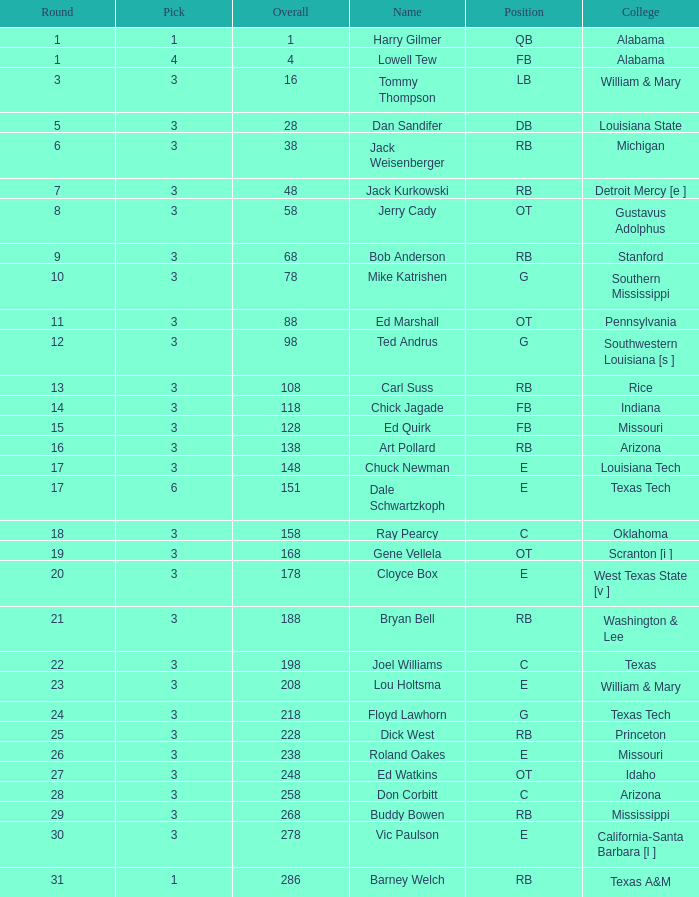Which selection has a round less than 8, and an overall less than 16, and a name of harry gilmer? 1.0. I'm looking to parse the entire table for insights. Could you assist me with that? {'header': ['Round', 'Pick', 'Overall', 'Name', 'Position', 'College'], 'rows': [['1', '1', '1', 'Harry Gilmer', 'QB', 'Alabama'], ['1', '4', '4', 'Lowell Tew', 'FB', 'Alabama'], ['3', '3', '16', 'Tommy Thompson', 'LB', 'William & Mary'], ['5', '3', '28', 'Dan Sandifer', 'DB', 'Louisiana State'], ['6', '3', '38', 'Jack Weisenberger', 'RB', 'Michigan'], ['7', '3', '48', 'Jack Kurkowski', 'RB', 'Detroit Mercy [e ]'], ['8', '3', '58', 'Jerry Cady', 'OT', 'Gustavus Adolphus'], ['9', '3', '68', 'Bob Anderson', 'RB', 'Stanford'], ['10', '3', '78', 'Mike Katrishen', 'G', 'Southern Mississippi'], ['11', '3', '88', 'Ed Marshall', 'OT', 'Pennsylvania'], ['12', '3', '98', 'Ted Andrus', 'G', 'Southwestern Louisiana [s ]'], ['13', '3', '108', 'Carl Suss', 'RB', 'Rice'], ['14', '3', '118', 'Chick Jagade', 'FB', 'Indiana'], ['15', '3', '128', 'Ed Quirk', 'FB', 'Missouri'], ['16', '3', '138', 'Art Pollard', 'RB', 'Arizona'], ['17', '3', '148', 'Chuck Newman', 'E', 'Louisiana Tech'], ['17', '6', '151', 'Dale Schwartzkoph', 'E', 'Texas Tech'], ['18', '3', '158', 'Ray Pearcy', 'C', 'Oklahoma'], ['19', '3', '168', 'Gene Vellela', 'OT', 'Scranton [i ]'], ['20', '3', '178', 'Cloyce Box', 'E', 'West Texas State [v ]'], ['21', '3', '188', 'Bryan Bell', 'RB', 'Washington & Lee'], ['22', '3', '198', 'Joel Williams', 'C', 'Texas'], ['23', '3', '208', 'Lou Holtsma', 'E', 'William & Mary'], ['24', '3', '218', 'Floyd Lawhorn', 'G', 'Texas Tech'], ['25', '3', '228', 'Dick West', 'RB', 'Princeton'], ['26', '3', '238', 'Roland Oakes', 'E', 'Missouri'], ['27', '3', '248', 'Ed Watkins', 'OT', 'Idaho'], ['28', '3', '258', 'Don Corbitt', 'C', 'Arizona'], ['29', '3', '268', 'Buddy Bowen', 'RB', 'Mississippi'], ['30', '3', '278', 'Vic Paulson', 'E', 'California-Santa Barbara [l ]'], ['31', '1', '286', 'Barney Welch', 'RB', 'Texas A&M']]} 